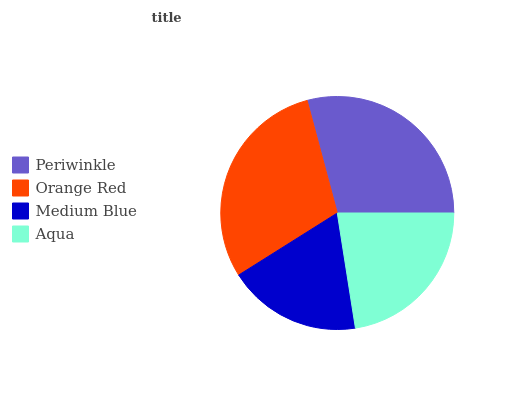Is Medium Blue the minimum?
Answer yes or no. Yes. Is Orange Red the maximum?
Answer yes or no. Yes. Is Orange Red the minimum?
Answer yes or no. No. Is Medium Blue the maximum?
Answer yes or no. No. Is Orange Red greater than Medium Blue?
Answer yes or no. Yes. Is Medium Blue less than Orange Red?
Answer yes or no. Yes. Is Medium Blue greater than Orange Red?
Answer yes or no. No. Is Orange Red less than Medium Blue?
Answer yes or no. No. Is Periwinkle the high median?
Answer yes or no. Yes. Is Aqua the low median?
Answer yes or no. Yes. Is Medium Blue the high median?
Answer yes or no. No. Is Orange Red the low median?
Answer yes or no. No. 